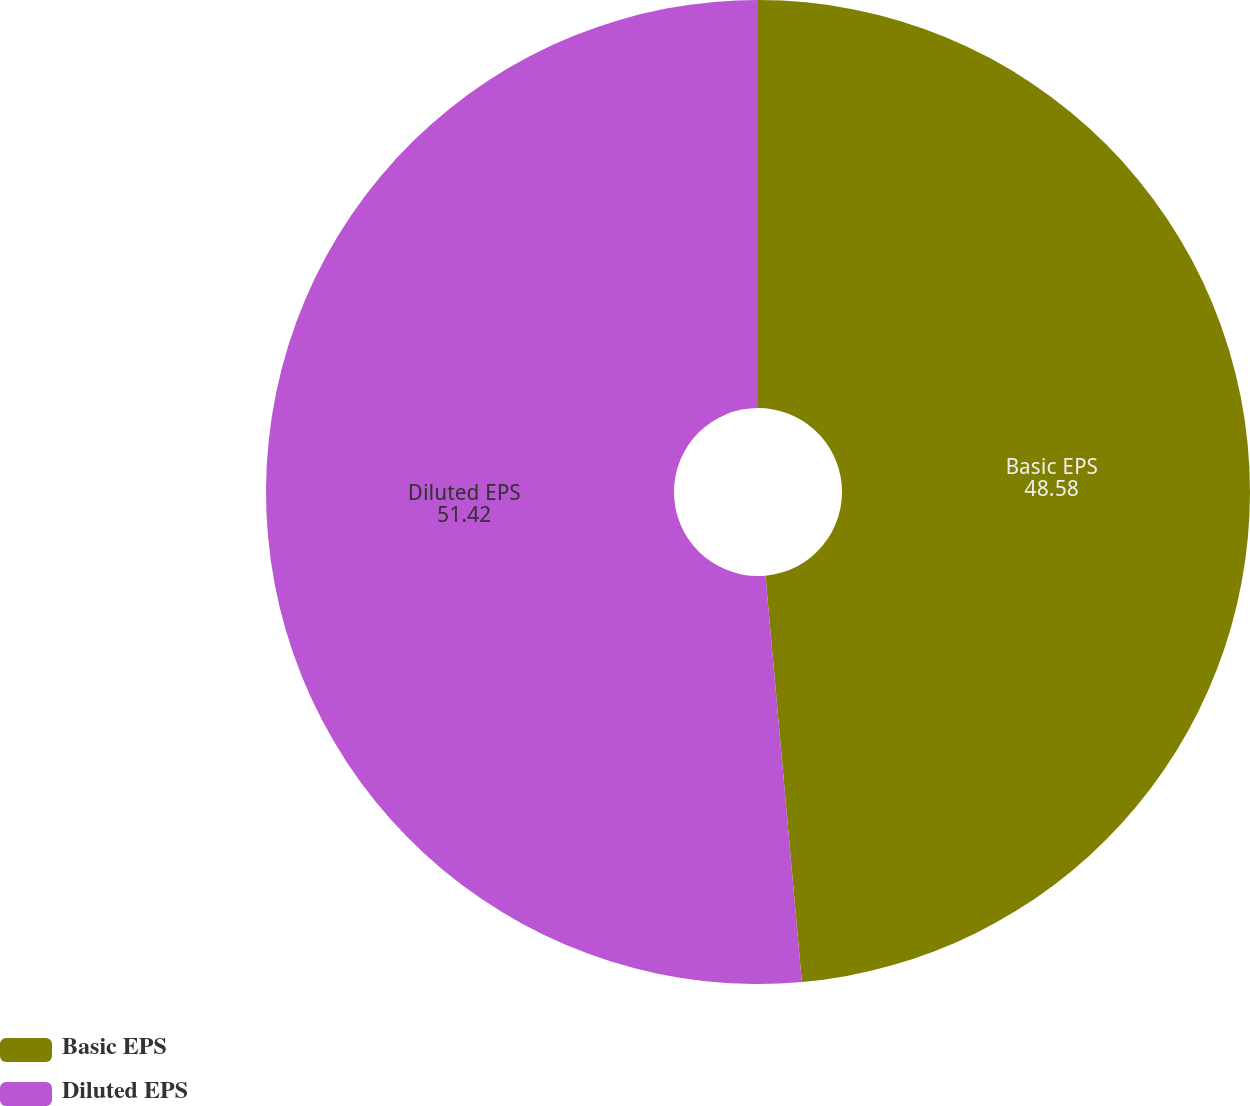<chart> <loc_0><loc_0><loc_500><loc_500><pie_chart><fcel>Basic EPS<fcel>Diluted EPS<nl><fcel>48.58%<fcel>51.42%<nl></chart> 